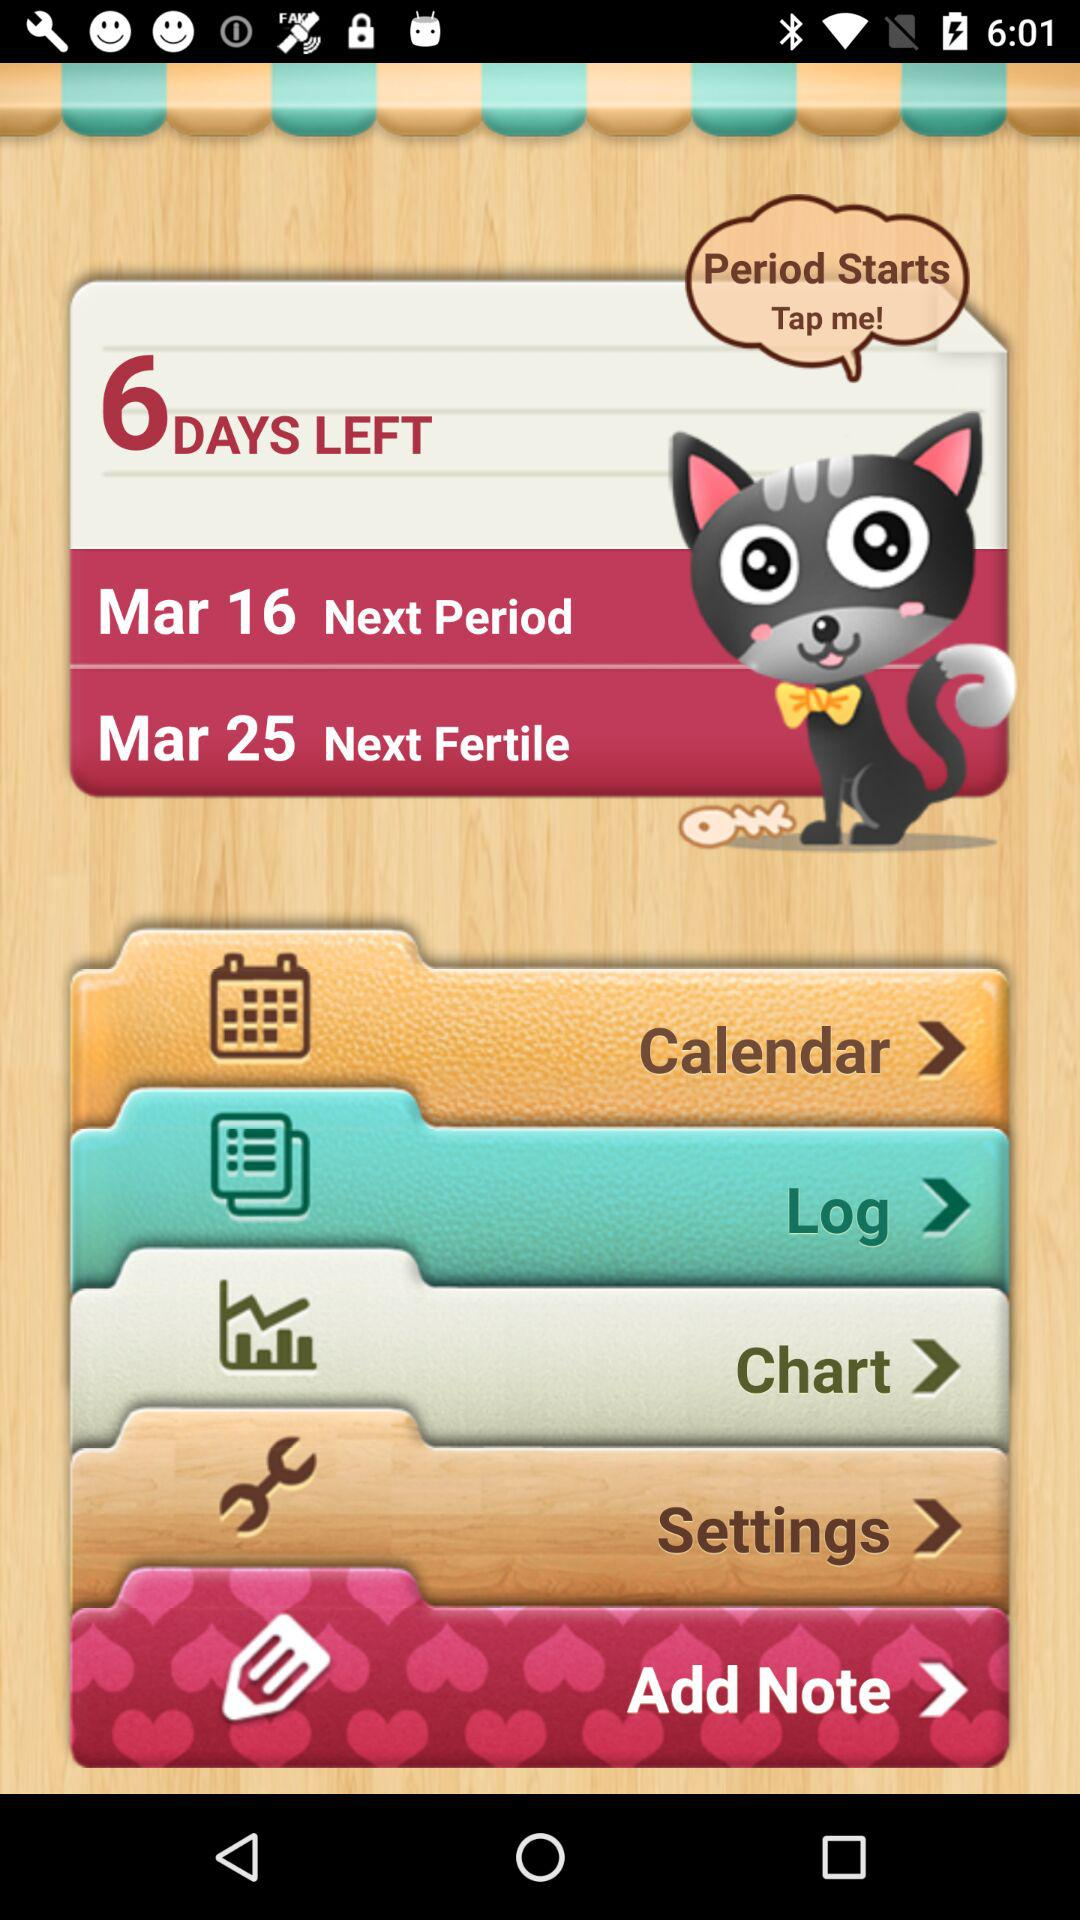What is the date of the next period? The date of the next period is March 16. 